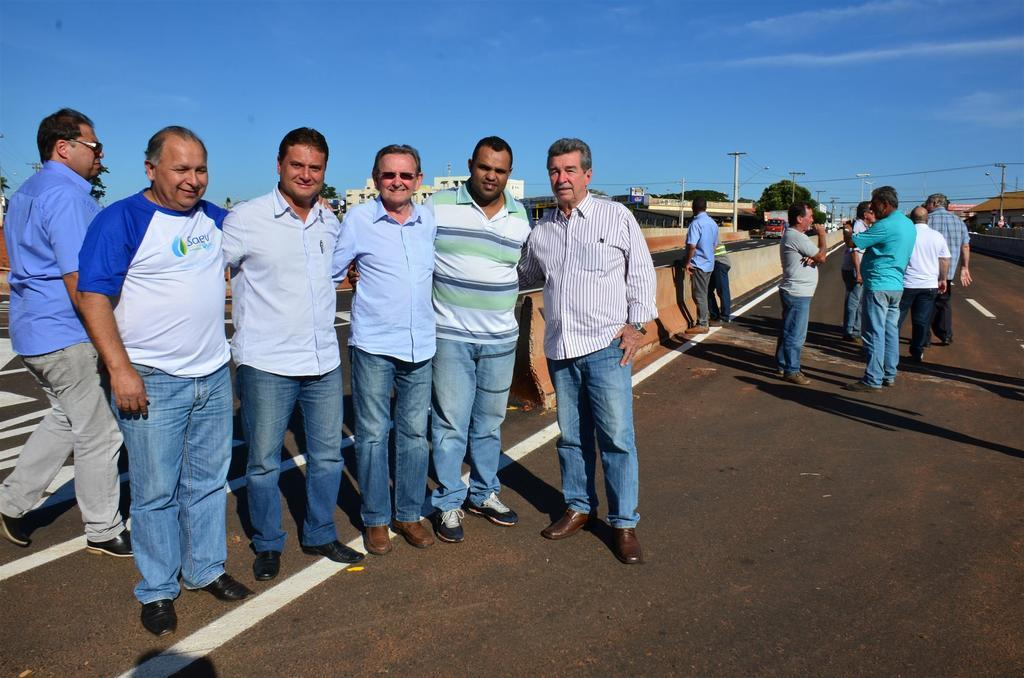What are the people in the image doing? The people in the image are standing on the road. What can be seen in the background of the image? Current poles with wires, buildings, trees, and the sky are visible in the background. How many children are wearing badges in the image? There are no children or badges present in the image. 